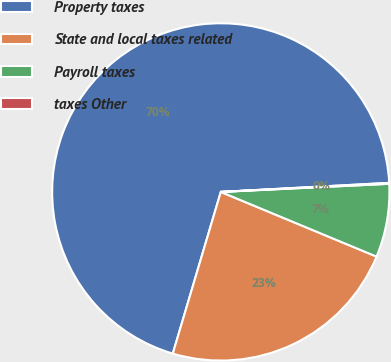Convert chart. <chart><loc_0><loc_0><loc_500><loc_500><pie_chart><fcel>Property taxes<fcel>State and local taxes related<fcel>Payroll taxes<fcel>taxes Other<nl><fcel>69.55%<fcel>23.33%<fcel>7.03%<fcel>0.09%<nl></chart> 